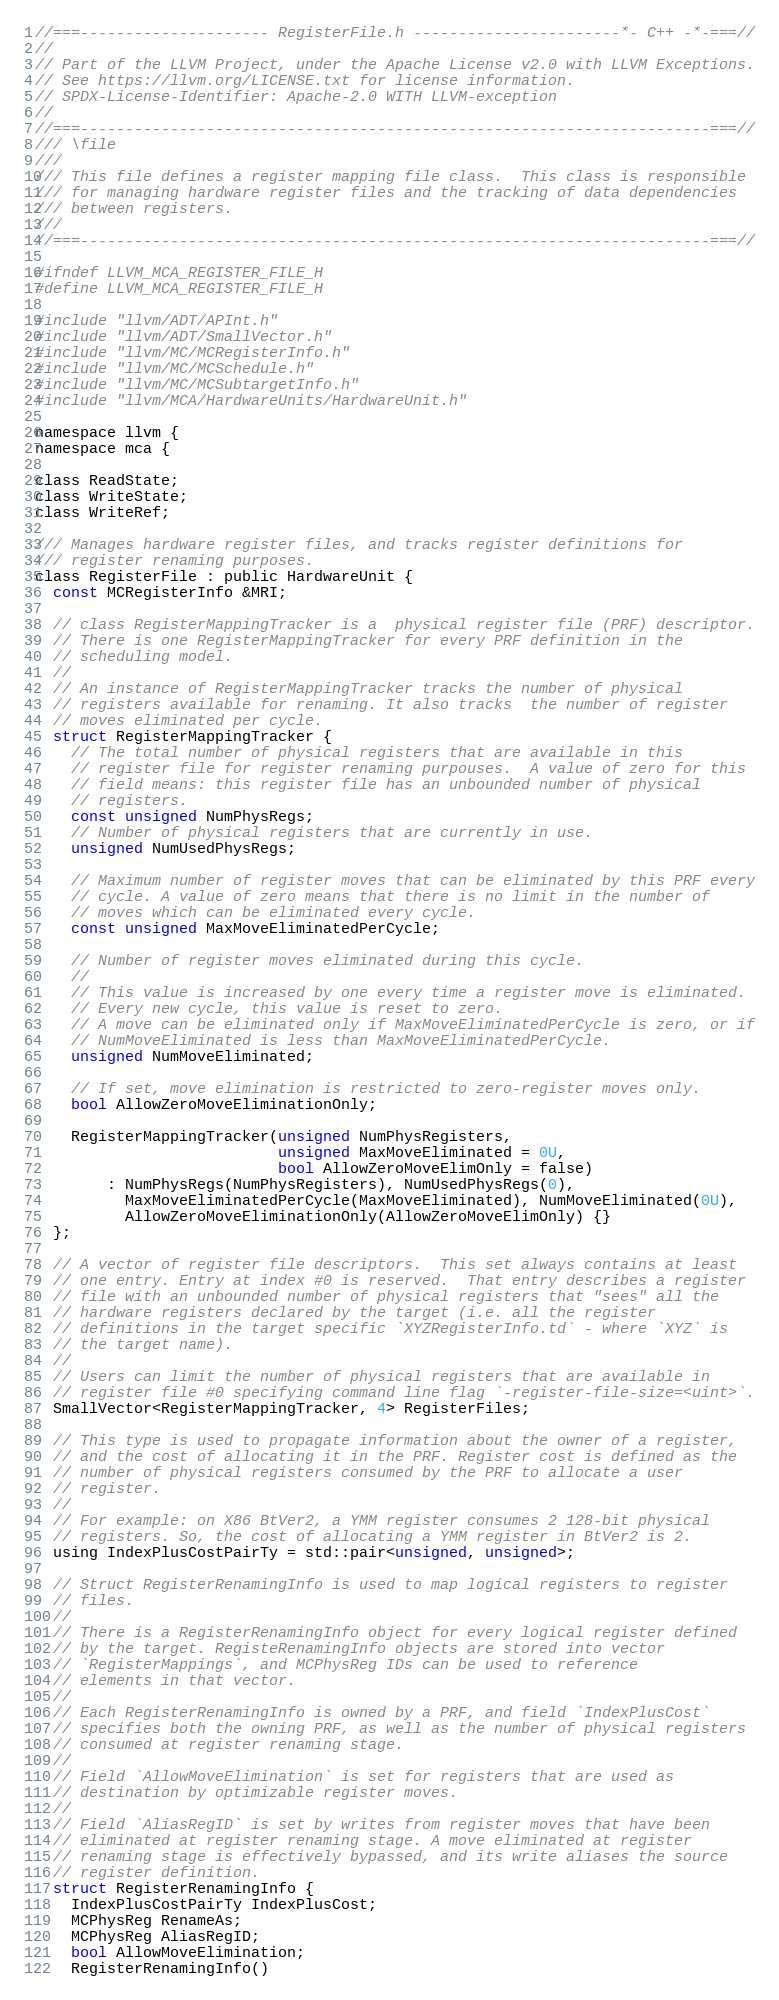Convert code to text. <code><loc_0><loc_0><loc_500><loc_500><_C_>//===--------------------- RegisterFile.h -----------------------*- C++ -*-===//
//
// Part of the LLVM Project, under the Apache License v2.0 with LLVM Exceptions.
// See https://llvm.org/LICENSE.txt for license information.
// SPDX-License-Identifier: Apache-2.0 WITH LLVM-exception
//
//===----------------------------------------------------------------------===//
/// \file
///
/// This file defines a register mapping file class.  This class is responsible
/// for managing hardware register files and the tracking of data dependencies
/// between registers.
///
//===----------------------------------------------------------------------===//

#ifndef LLVM_MCA_REGISTER_FILE_H
#define LLVM_MCA_REGISTER_FILE_H

#include "llvm/ADT/APInt.h"
#include "llvm/ADT/SmallVector.h"
#include "llvm/MC/MCRegisterInfo.h"
#include "llvm/MC/MCSchedule.h"
#include "llvm/MC/MCSubtargetInfo.h"
#include "llvm/MCA/HardwareUnits/HardwareUnit.h"

namespace llvm {
namespace mca {

class ReadState;
class WriteState;
class WriteRef;

/// Manages hardware register files, and tracks register definitions for
/// register renaming purposes.
class RegisterFile : public HardwareUnit {
  const MCRegisterInfo &MRI;

  // class RegisterMappingTracker is a  physical register file (PRF) descriptor.
  // There is one RegisterMappingTracker for every PRF definition in the
  // scheduling model.
  //
  // An instance of RegisterMappingTracker tracks the number of physical
  // registers available for renaming. It also tracks  the number of register
  // moves eliminated per cycle.
  struct RegisterMappingTracker {
    // The total number of physical registers that are available in this
    // register file for register renaming purpouses.  A value of zero for this
    // field means: this register file has an unbounded number of physical
    // registers.
    const unsigned NumPhysRegs;
    // Number of physical registers that are currently in use.
    unsigned NumUsedPhysRegs;

    // Maximum number of register moves that can be eliminated by this PRF every
    // cycle. A value of zero means that there is no limit in the number of
    // moves which can be eliminated every cycle.
    const unsigned MaxMoveEliminatedPerCycle;

    // Number of register moves eliminated during this cycle.
    //
    // This value is increased by one every time a register move is eliminated.
    // Every new cycle, this value is reset to zero.
    // A move can be eliminated only if MaxMoveEliminatedPerCycle is zero, or if
    // NumMoveEliminated is less than MaxMoveEliminatedPerCycle.
    unsigned NumMoveEliminated;

    // If set, move elimination is restricted to zero-register moves only.
    bool AllowZeroMoveEliminationOnly;

    RegisterMappingTracker(unsigned NumPhysRegisters,
                           unsigned MaxMoveEliminated = 0U,
                           bool AllowZeroMoveElimOnly = false)
        : NumPhysRegs(NumPhysRegisters), NumUsedPhysRegs(0),
          MaxMoveEliminatedPerCycle(MaxMoveEliminated), NumMoveEliminated(0U),
          AllowZeroMoveEliminationOnly(AllowZeroMoveElimOnly) {}
  };

  // A vector of register file descriptors.  This set always contains at least
  // one entry. Entry at index #0 is reserved.  That entry describes a register
  // file with an unbounded number of physical registers that "sees" all the
  // hardware registers declared by the target (i.e. all the register
  // definitions in the target specific `XYZRegisterInfo.td` - where `XYZ` is
  // the target name).
  //
  // Users can limit the number of physical registers that are available in
  // register file #0 specifying command line flag `-register-file-size=<uint>`.
  SmallVector<RegisterMappingTracker, 4> RegisterFiles;

  // This type is used to propagate information about the owner of a register,
  // and the cost of allocating it in the PRF. Register cost is defined as the
  // number of physical registers consumed by the PRF to allocate a user
  // register.
  //
  // For example: on X86 BtVer2, a YMM register consumes 2 128-bit physical
  // registers. So, the cost of allocating a YMM register in BtVer2 is 2.
  using IndexPlusCostPairTy = std::pair<unsigned, unsigned>;

  // Struct RegisterRenamingInfo is used to map logical registers to register
  // files.
  //
  // There is a RegisterRenamingInfo object for every logical register defined
  // by the target. RegisteRenamingInfo objects are stored into vector
  // `RegisterMappings`, and MCPhysReg IDs can be used to reference
  // elements in that vector.
  //
  // Each RegisterRenamingInfo is owned by a PRF, and field `IndexPlusCost`
  // specifies both the owning PRF, as well as the number of physical registers
  // consumed at register renaming stage.
  //
  // Field `AllowMoveElimination` is set for registers that are used as
  // destination by optimizable register moves.
  //
  // Field `AliasRegID` is set by writes from register moves that have been
  // eliminated at register renaming stage. A move eliminated at register
  // renaming stage is effectively bypassed, and its write aliases the source
  // register definition.
  struct RegisterRenamingInfo {
    IndexPlusCostPairTy IndexPlusCost;
    MCPhysReg RenameAs;
    MCPhysReg AliasRegID;
    bool AllowMoveElimination;
    RegisterRenamingInfo()</code> 